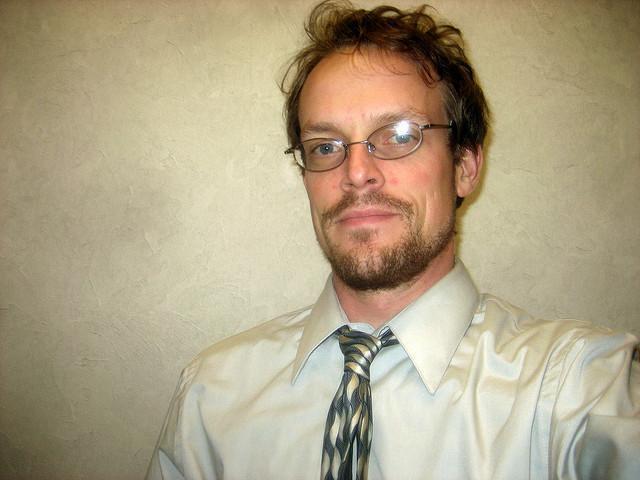How many ties can be seen?
Give a very brief answer. 1. How many donuts are glazed?
Give a very brief answer. 0. 